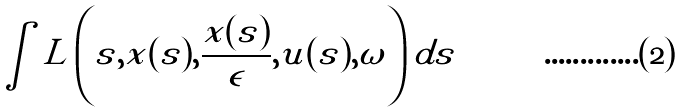<formula> <loc_0><loc_0><loc_500><loc_500>\int L \left ( s , x ( s ) , \frac { x ( s ) } { \epsilon } , u ( s ) , \omega \right ) d s</formula> 